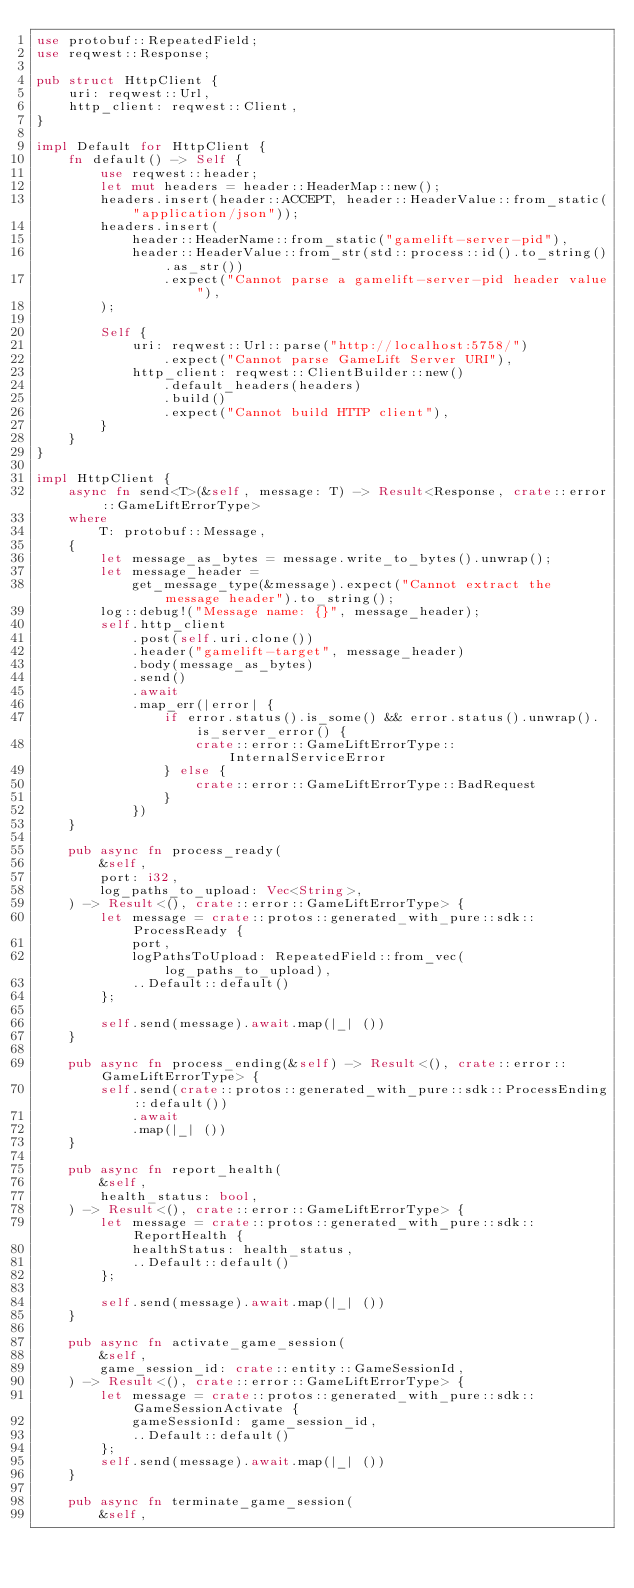Convert code to text. <code><loc_0><loc_0><loc_500><loc_500><_Rust_>use protobuf::RepeatedField;
use reqwest::Response;

pub struct HttpClient {
    uri: reqwest::Url,
    http_client: reqwest::Client,
}

impl Default for HttpClient {
    fn default() -> Self {
        use reqwest::header;
        let mut headers = header::HeaderMap::new();
        headers.insert(header::ACCEPT, header::HeaderValue::from_static("application/json"));
        headers.insert(
            header::HeaderName::from_static("gamelift-server-pid"),
            header::HeaderValue::from_str(std::process::id().to_string().as_str())
                .expect("Cannot parse a gamelift-server-pid header value"),
        );

        Self {
            uri: reqwest::Url::parse("http://localhost:5758/")
                .expect("Cannot parse GameLift Server URI"),
            http_client: reqwest::ClientBuilder::new()
                .default_headers(headers)
                .build()
                .expect("Cannot build HTTP client"),
        }
    }
}

impl HttpClient {
    async fn send<T>(&self, message: T) -> Result<Response, crate::error::GameLiftErrorType>
    where
        T: protobuf::Message,
    {
        let message_as_bytes = message.write_to_bytes().unwrap();
        let message_header =
            get_message_type(&message).expect("Cannot extract the message header").to_string();
        log::debug!("Message name: {}", message_header);
        self.http_client
            .post(self.uri.clone())
            .header("gamelift-target", message_header)
            .body(message_as_bytes)
            .send()
            .await
            .map_err(|error| {
                if error.status().is_some() && error.status().unwrap().is_server_error() {
                    crate::error::GameLiftErrorType::InternalServiceError
                } else {
                    crate::error::GameLiftErrorType::BadRequest
                }
            })
    }

    pub async fn process_ready(
        &self,
        port: i32,
        log_paths_to_upload: Vec<String>,
    ) -> Result<(), crate::error::GameLiftErrorType> {
        let message = crate::protos::generated_with_pure::sdk::ProcessReady {
            port,
            logPathsToUpload: RepeatedField::from_vec(log_paths_to_upload),
            ..Default::default()
        };

        self.send(message).await.map(|_| ())
    }

    pub async fn process_ending(&self) -> Result<(), crate::error::GameLiftErrorType> {
        self.send(crate::protos::generated_with_pure::sdk::ProcessEnding::default())
            .await
            .map(|_| ())
    }

    pub async fn report_health(
        &self,
        health_status: bool,
    ) -> Result<(), crate::error::GameLiftErrorType> {
        let message = crate::protos::generated_with_pure::sdk::ReportHealth {
            healthStatus: health_status,
            ..Default::default()
        };

        self.send(message).await.map(|_| ())
    }

    pub async fn activate_game_session(
        &self,
        game_session_id: crate::entity::GameSessionId,
    ) -> Result<(), crate::error::GameLiftErrorType> {
        let message = crate::protos::generated_with_pure::sdk::GameSessionActivate {
            gameSessionId: game_session_id,
            ..Default::default()
        };
        self.send(message).await.map(|_| ())
    }

    pub async fn terminate_game_session(
        &self,</code> 